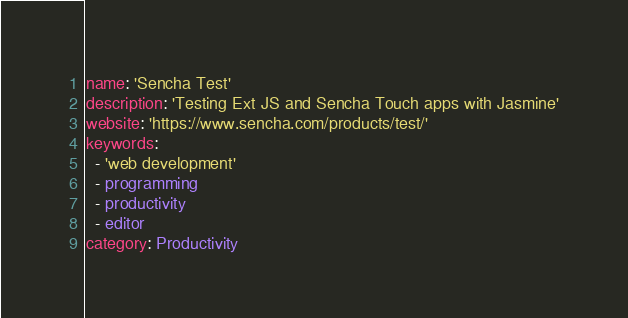<code> <loc_0><loc_0><loc_500><loc_500><_YAML_>name: 'Sencha Test'
description: 'Testing Ext JS and Sencha Touch apps with Jasmine'
website: 'https://www.sencha.com/products/test/'
keywords:
  - 'web development'
  - programming
  - productivity
  - editor
category: Productivity
</code> 